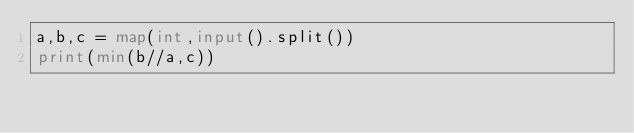Convert code to text. <code><loc_0><loc_0><loc_500><loc_500><_Python_>a,b,c = map(int,input().split())
print(min(b//a,c))</code> 